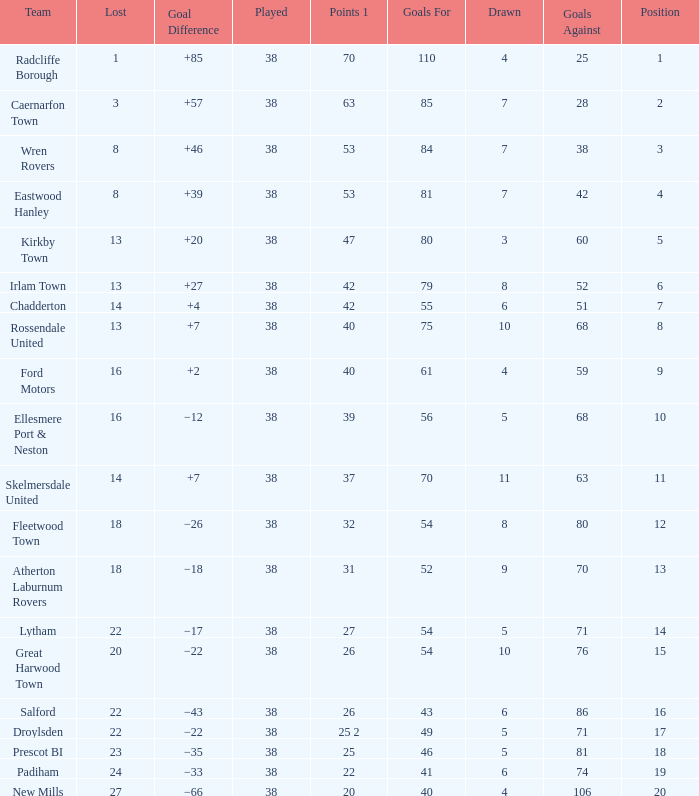Which Lost has a Position larger than 5, and Points 1 of 37, and less than 63 Goals Against? None. 